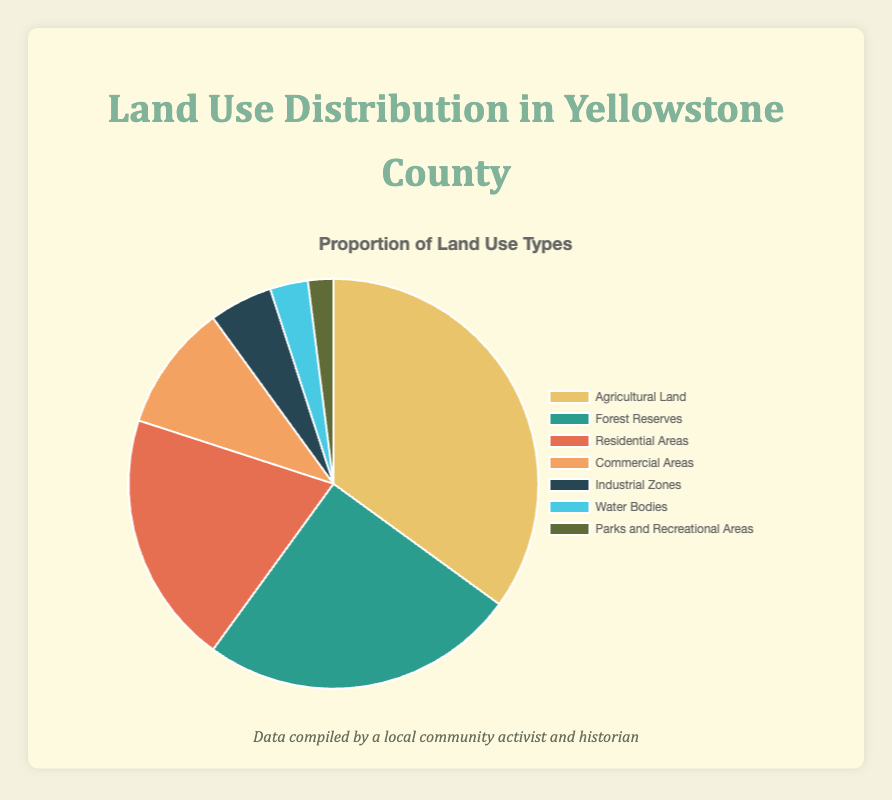What proportion of Yellowstone County is used for Agricultural Land? The pie chart shows that Agricultural Land occupies 35% of the total land use in Yellowstone County.
Answer: 35% What is the total percentage of land used for Residential Areas and Commercial Areas combined? Adding the proportions for Residential Areas (20%) and Commercial Areas (10%) gives us 30%.
Answer: 30% Which land use type occupies the smallest proportion of land in Yellowstone County? From the chart, Parks and Recreational Areas occupy the smallest proportion at 2%.
Answer: Parks and Recreational Areas How much more land is used for Forest Reserves compared to Industrial Zones? The percentage for Forest Reserves is 25%, while Industrial Zones account for 5%. The difference is 25% - 5% = 20%.
Answer: 20% Are Residential Areas used more or less than Agricultural Land? Residential Areas occupy 20% of the land, whereas Agricultural Land occupies 35%. Therefore, Residential Areas are used less than Agricultural Land.
Answer: Less What percentage of land is non-commercial (excluding Commercial Areas)? To find this, subtract the percentage of Commercial Areas (10%) from 100%. 100% - 10% = 90%.
Answer: 90% Which land use type is represented by the second largest slice on the pie chart? The second largest slice on the pie chart corresponds to Forest Reserves, which occupies 25% of the land.
Answer: Forest Reserves What is the combined proportion of land used for Water Bodies and Parks and Recreational Areas? The percentage for Water Bodies is 3% and for Parks and Recreational Areas is 2%. Adding them gives 3% + 2% = 5%.
Answer: 5% Identify the land use type represented by the color green. In the pie chart, Forest Reserves are represented by the color green and they occupy 25% of the land.
Answer: Forest Reserves How does the land used for Water Bodies compare to that of Industrial Zones? Water Bodies take up 3% of the land, while Industrial Zones occupy 5%, making Industrial Zones usage higher by 2%.
Answer: Industrial Zones occupy more 